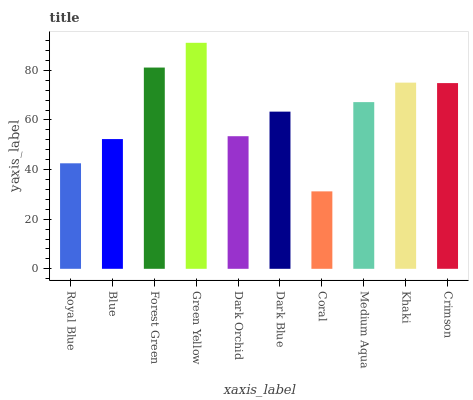Is Blue the minimum?
Answer yes or no. No. Is Blue the maximum?
Answer yes or no. No. Is Blue greater than Royal Blue?
Answer yes or no. Yes. Is Royal Blue less than Blue?
Answer yes or no. Yes. Is Royal Blue greater than Blue?
Answer yes or no. No. Is Blue less than Royal Blue?
Answer yes or no. No. Is Medium Aqua the high median?
Answer yes or no. Yes. Is Dark Blue the low median?
Answer yes or no. Yes. Is Green Yellow the high median?
Answer yes or no. No. Is Royal Blue the low median?
Answer yes or no. No. 